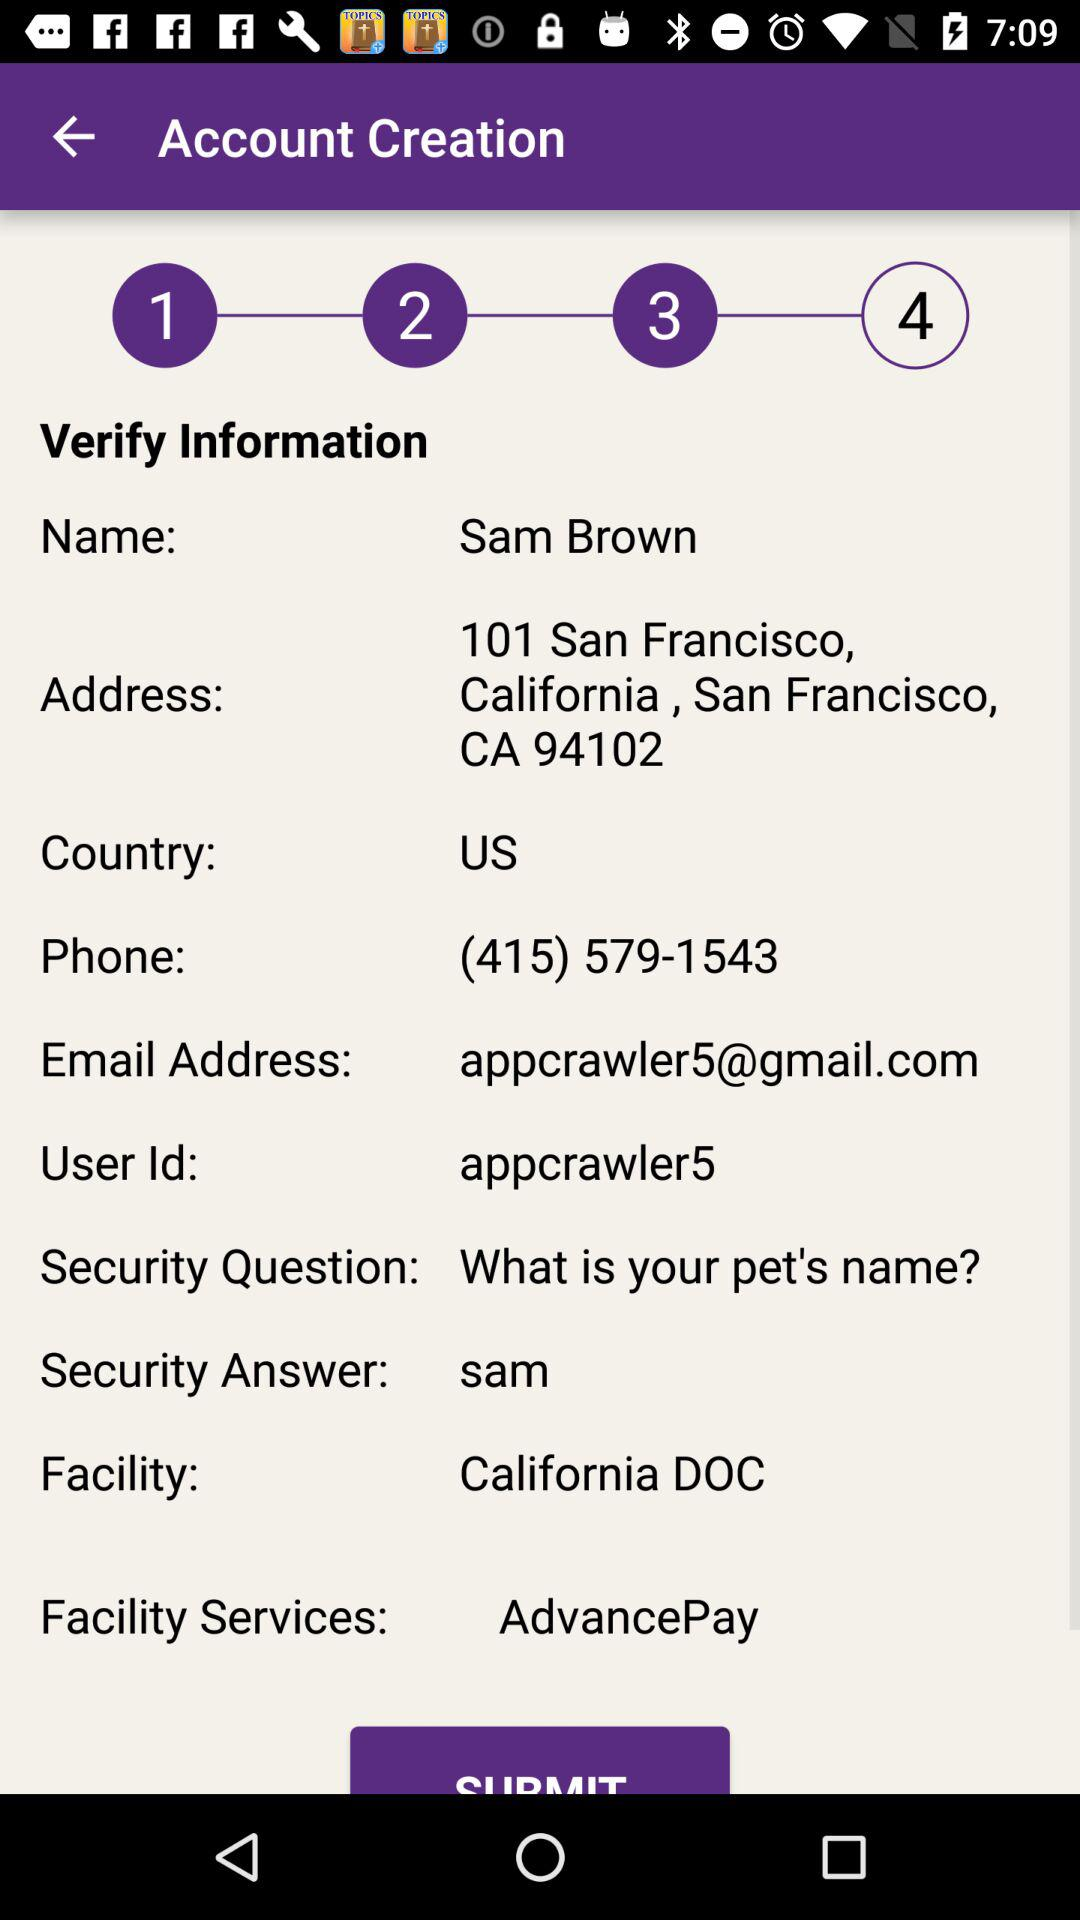What is the email id of sam? What is the email ID of Sam? The email ID of Sam is appcrawler5@gmail.com. 